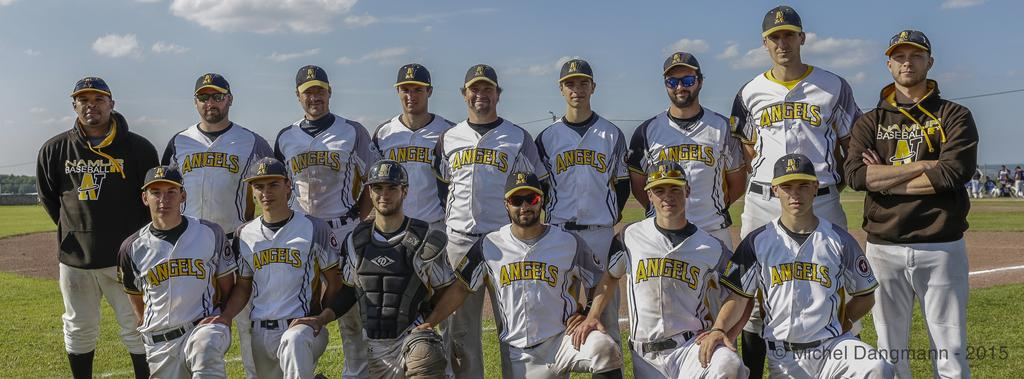<image>
Create a compact narrative representing the image presented. Baseball team with a jersey saying angels on the front. 